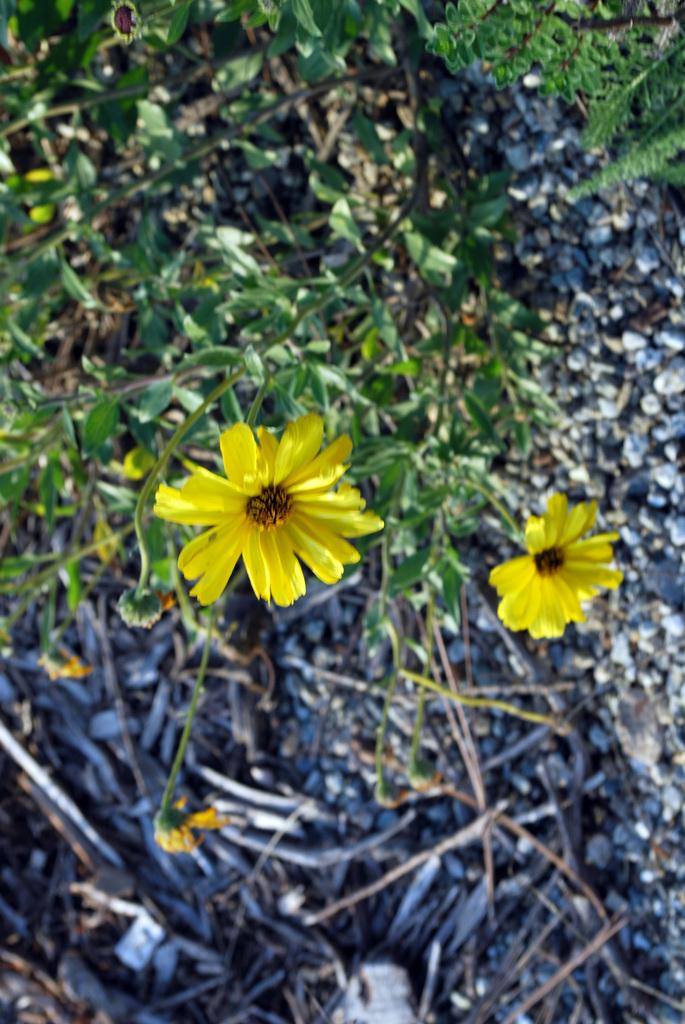What type of plants are in the image? The plants in the image have yellow flowers and green leaves. What colors are present in the flowers of the plants? The flowers of the plants are yellow. What else can be seen on the ground in the image? There are sticks and stones on the ground in the image. What color are the leaves of the plants? The leaves of the plants are green. How much ink is spilled on the ground in the image? There is no ink spilled on the ground in the image. What type of loss is depicted in the image? There is no loss depicted in the image; it features plants with yellow flowers and green leaves, as well as sticks and stones on the ground. 